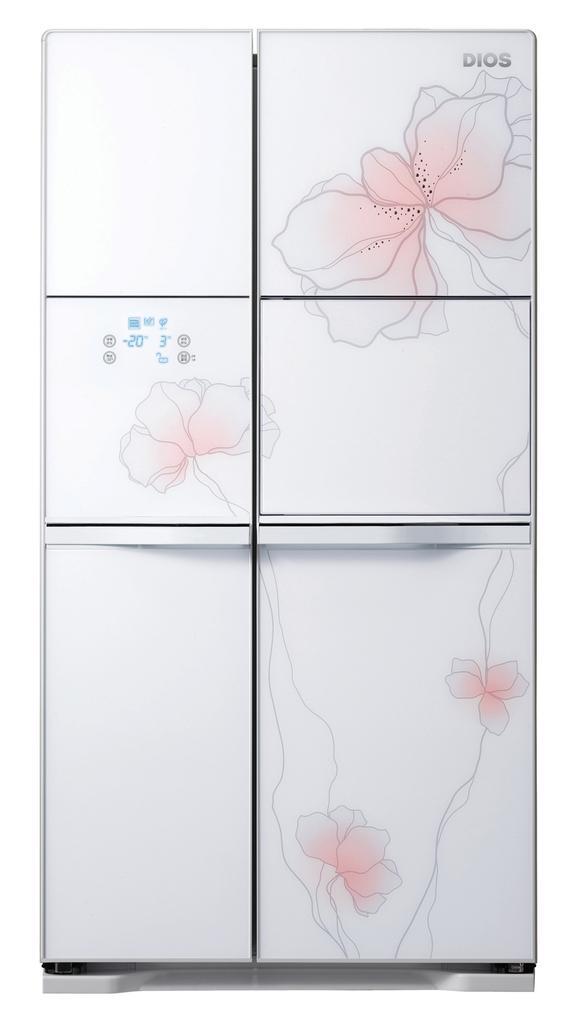Describe this image in one or two sentences. In this image I can see the white color refrigerator and there are some flowers on it. And there is a white background. 